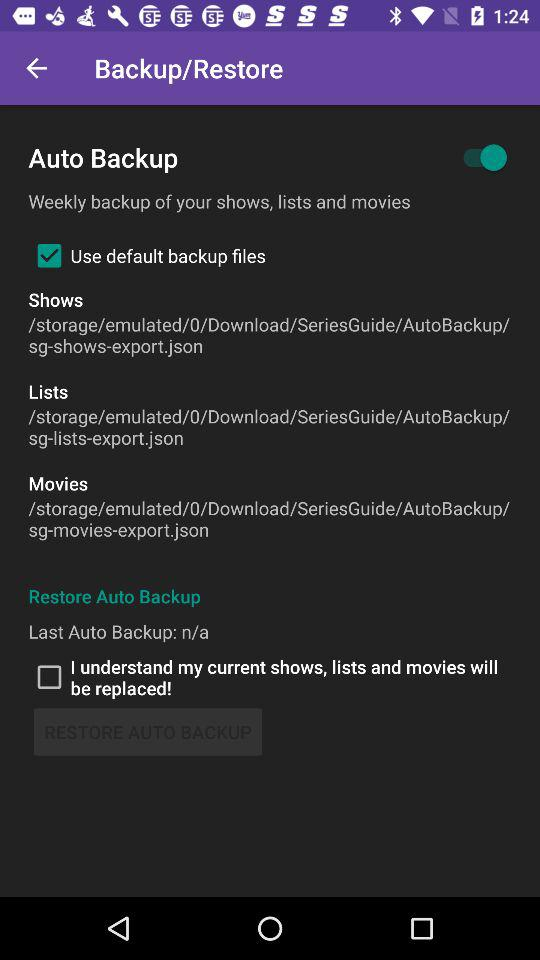What is the current status of "I understand my current shows, lists and movies will be replaced!"? The status is "off". 